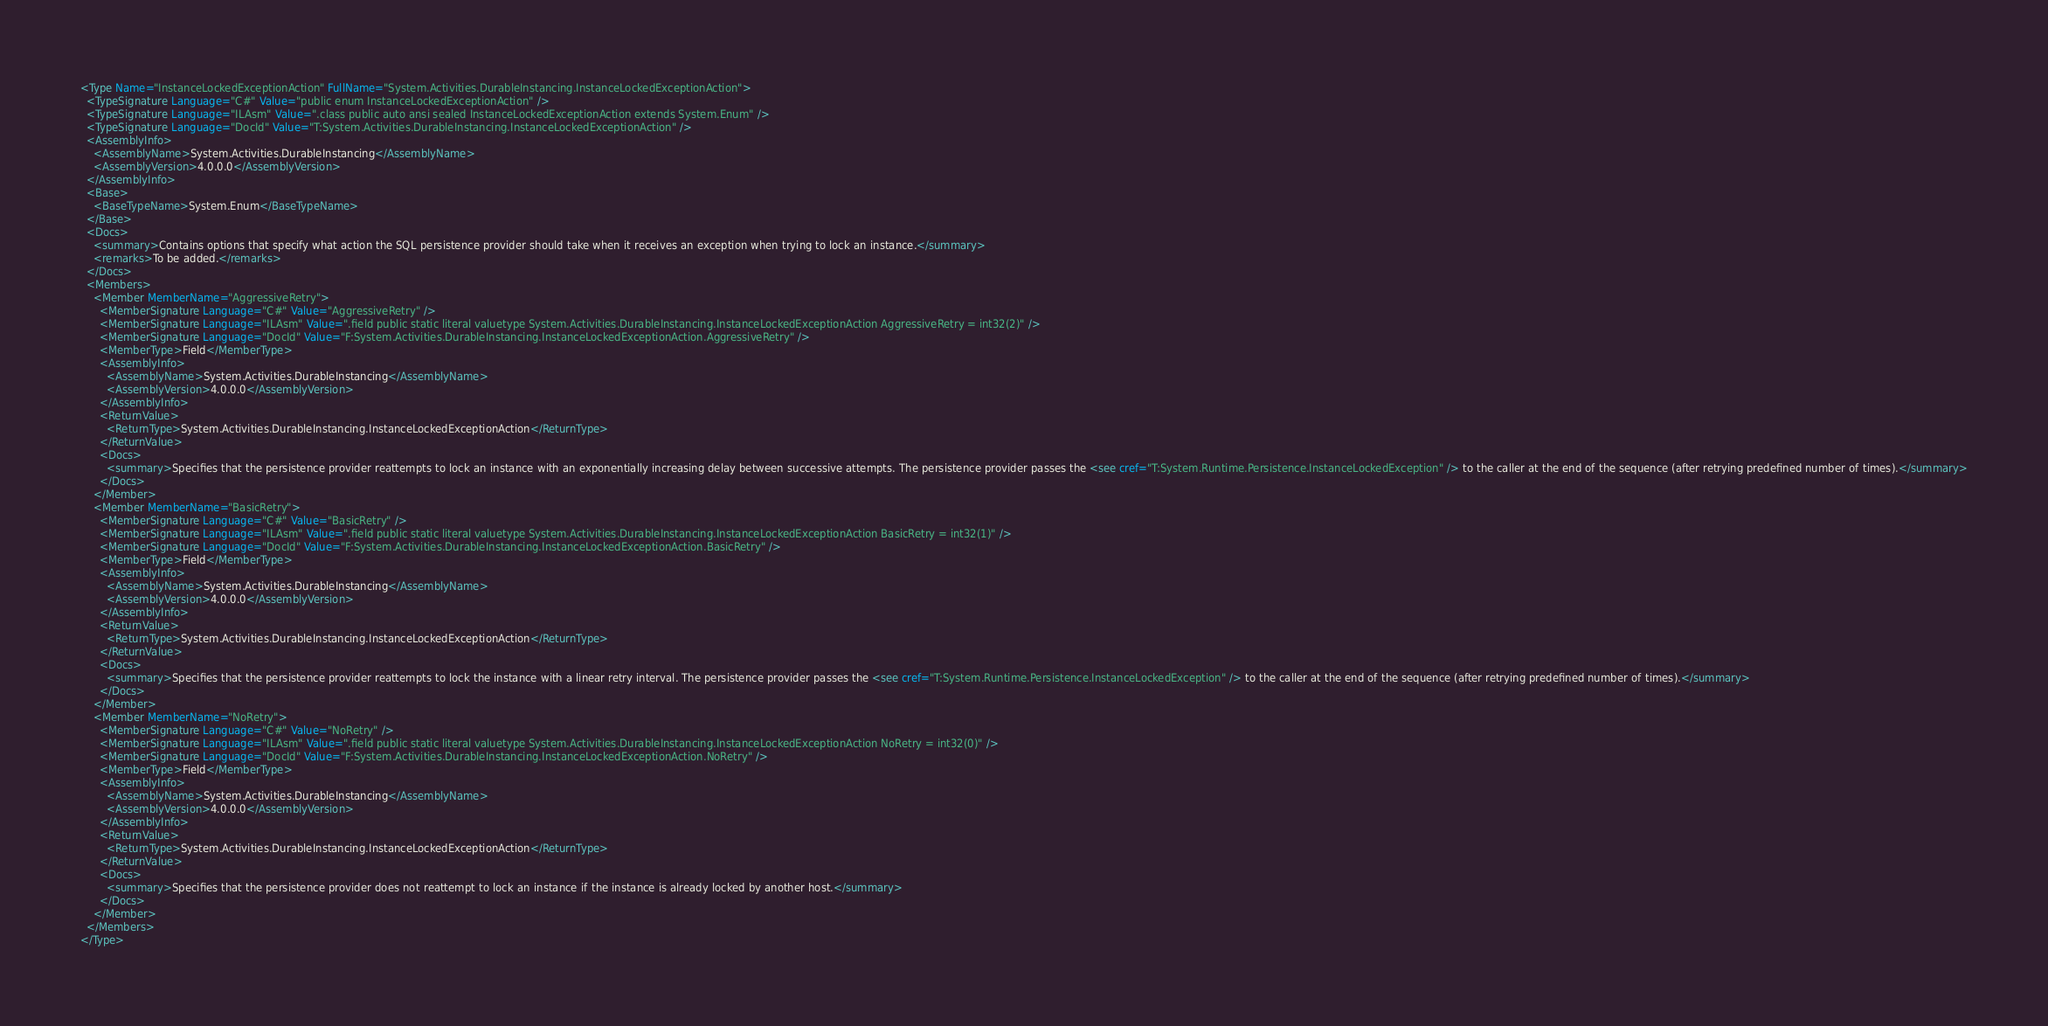Convert code to text. <code><loc_0><loc_0><loc_500><loc_500><_XML_><Type Name="InstanceLockedExceptionAction" FullName="System.Activities.DurableInstancing.InstanceLockedExceptionAction">
  <TypeSignature Language="C#" Value="public enum InstanceLockedExceptionAction" />
  <TypeSignature Language="ILAsm" Value=".class public auto ansi sealed InstanceLockedExceptionAction extends System.Enum" />
  <TypeSignature Language="DocId" Value="T:System.Activities.DurableInstancing.InstanceLockedExceptionAction" />
  <AssemblyInfo>
    <AssemblyName>System.Activities.DurableInstancing</AssemblyName>
    <AssemblyVersion>4.0.0.0</AssemblyVersion>
  </AssemblyInfo>
  <Base>
    <BaseTypeName>System.Enum</BaseTypeName>
  </Base>
  <Docs>
    <summary>Contains options that specify what action the SQL persistence provider should take when it receives an exception when trying to lock an instance.</summary>
    <remarks>To be added.</remarks>
  </Docs>
  <Members>
    <Member MemberName="AggressiveRetry">
      <MemberSignature Language="C#" Value="AggressiveRetry" />
      <MemberSignature Language="ILAsm" Value=".field public static literal valuetype System.Activities.DurableInstancing.InstanceLockedExceptionAction AggressiveRetry = int32(2)" />
      <MemberSignature Language="DocId" Value="F:System.Activities.DurableInstancing.InstanceLockedExceptionAction.AggressiveRetry" />
      <MemberType>Field</MemberType>
      <AssemblyInfo>
        <AssemblyName>System.Activities.DurableInstancing</AssemblyName>
        <AssemblyVersion>4.0.0.0</AssemblyVersion>
      </AssemblyInfo>
      <ReturnValue>
        <ReturnType>System.Activities.DurableInstancing.InstanceLockedExceptionAction</ReturnType>
      </ReturnValue>
      <Docs>
        <summary>Specifies that the persistence provider reattempts to lock an instance with an exponentially increasing delay between successive attempts. The persistence provider passes the <see cref="T:System.Runtime.Persistence.InstanceLockedException" /> to the caller at the end of the sequence (after retrying predefined number of times).</summary>
      </Docs>
    </Member>
    <Member MemberName="BasicRetry">
      <MemberSignature Language="C#" Value="BasicRetry" />
      <MemberSignature Language="ILAsm" Value=".field public static literal valuetype System.Activities.DurableInstancing.InstanceLockedExceptionAction BasicRetry = int32(1)" />
      <MemberSignature Language="DocId" Value="F:System.Activities.DurableInstancing.InstanceLockedExceptionAction.BasicRetry" />
      <MemberType>Field</MemberType>
      <AssemblyInfo>
        <AssemblyName>System.Activities.DurableInstancing</AssemblyName>
        <AssemblyVersion>4.0.0.0</AssemblyVersion>
      </AssemblyInfo>
      <ReturnValue>
        <ReturnType>System.Activities.DurableInstancing.InstanceLockedExceptionAction</ReturnType>
      </ReturnValue>
      <Docs>
        <summary>Specifies that the persistence provider reattempts to lock the instance with a linear retry interval. The persistence provider passes the <see cref="T:System.Runtime.Persistence.InstanceLockedException" /> to the caller at the end of the sequence (after retrying predefined number of times).</summary>
      </Docs>
    </Member>
    <Member MemberName="NoRetry">
      <MemberSignature Language="C#" Value="NoRetry" />
      <MemberSignature Language="ILAsm" Value=".field public static literal valuetype System.Activities.DurableInstancing.InstanceLockedExceptionAction NoRetry = int32(0)" />
      <MemberSignature Language="DocId" Value="F:System.Activities.DurableInstancing.InstanceLockedExceptionAction.NoRetry" />
      <MemberType>Field</MemberType>
      <AssemblyInfo>
        <AssemblyName>System.Activities.DurableInstancing</AssemblyName>
        <AssemblyVersion>4.0.0.0</AssemblyVersion>
      </AssemblyInfo>
      <ReturnValue>
        <ReturnType>System.Activities.DurableInstancing.InstanceLockedExceptionAction</ReturnType>
      </ReturnValue>
      <Docs>
        <summary>Specifies that the persistence provider does not reattempt to lock an instance if the instance is already locked by another host.</summary>
      </Docs>
    </Member>
  </Members>
</Type></code> 